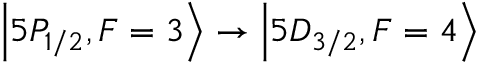Convert formula to latex. <formula><loc_0><loc_0><loc_500><loc_500>{ \left | 5 P _ { 1 / 2 } , F = 3 \right \rangle } \rightarrow { \left | 5 D _ { 3 / 2 } , F = 4 \right \rangle }</formula> 